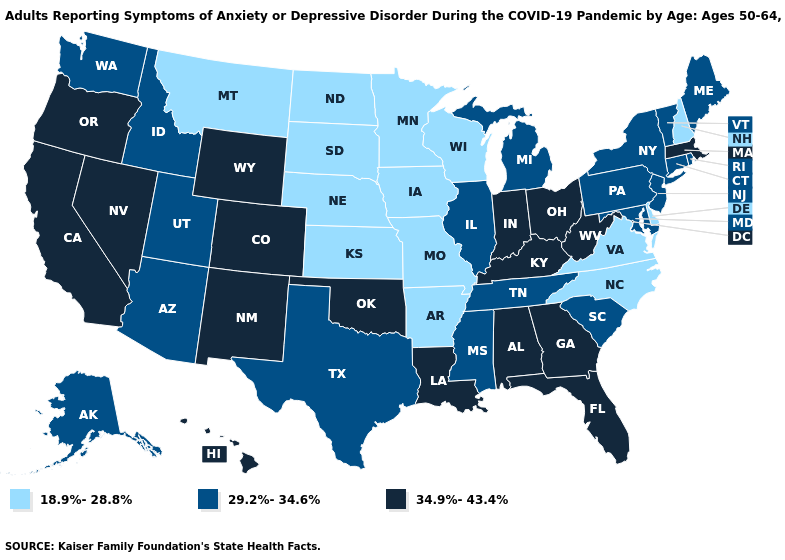What is the lowest value in states that border Wisconsin?
Short answer required. 18.9%-28.8%. Name the states that have a value in the range 29.2%-34.6%?
Answer briefly. Alaska, Arizona, Connecticut, Idaho, Illinois, Maine, Maryland, Michigan, Mississippi, New Jersey, New York, Pennsylvania, Rhode Island, South Carolina, Tennessee, Texas, Utah, Vermont, Washington. Which states hav the highest value in the Northeast?
Answer briefly. Massachusetts. Name the states that have a value in the range 29.2%-34.6%?
Keep it brief. Alaska, Arizona, Connecticut, Idaho, Illinois, Maine, Maryland, Michigan, Mississippi, New Jersey, New York, Pennsylvania, Rhode Island, South Carolina, Tennessee, Texas, Utah, Vermont, Washington. What is the value of Missouri?
Be succinct. 18.9%-28.8%. Does Oklahoma have the same value as Nebraska?
Short answer required. No. What is the value of Utah?
Short answer required. 29.2%-34.6%. How many symbols are there in the legend?
Short answer required. 3. What is the highest value in the USA?
Give a very brief answer. 34.9%-43.4%. Does Iowa have the lowest value in the USA?
Answer briefly. Yes. Does Alabama have the lowest value in the South?
Short answer required. No. What is the lowest value in the Northeast?
Keep it brief. 18.9%-28.8%. Does Nebraska have the lowest value in the USA?
Keep it brief. Yes. What is the value of Delaware?
Quick response, please. 18.9%-28.8%. Name the states that have a value in the range 18.9%-28.8%?
Be succinct. Arkansas, Delaware, Iowa, Kansas, Minnesota, Missouri, Montana, Nebraska, New Hampshire, North Carolina, North Dakota, South Dakota, Virginia, Wisconsin. 